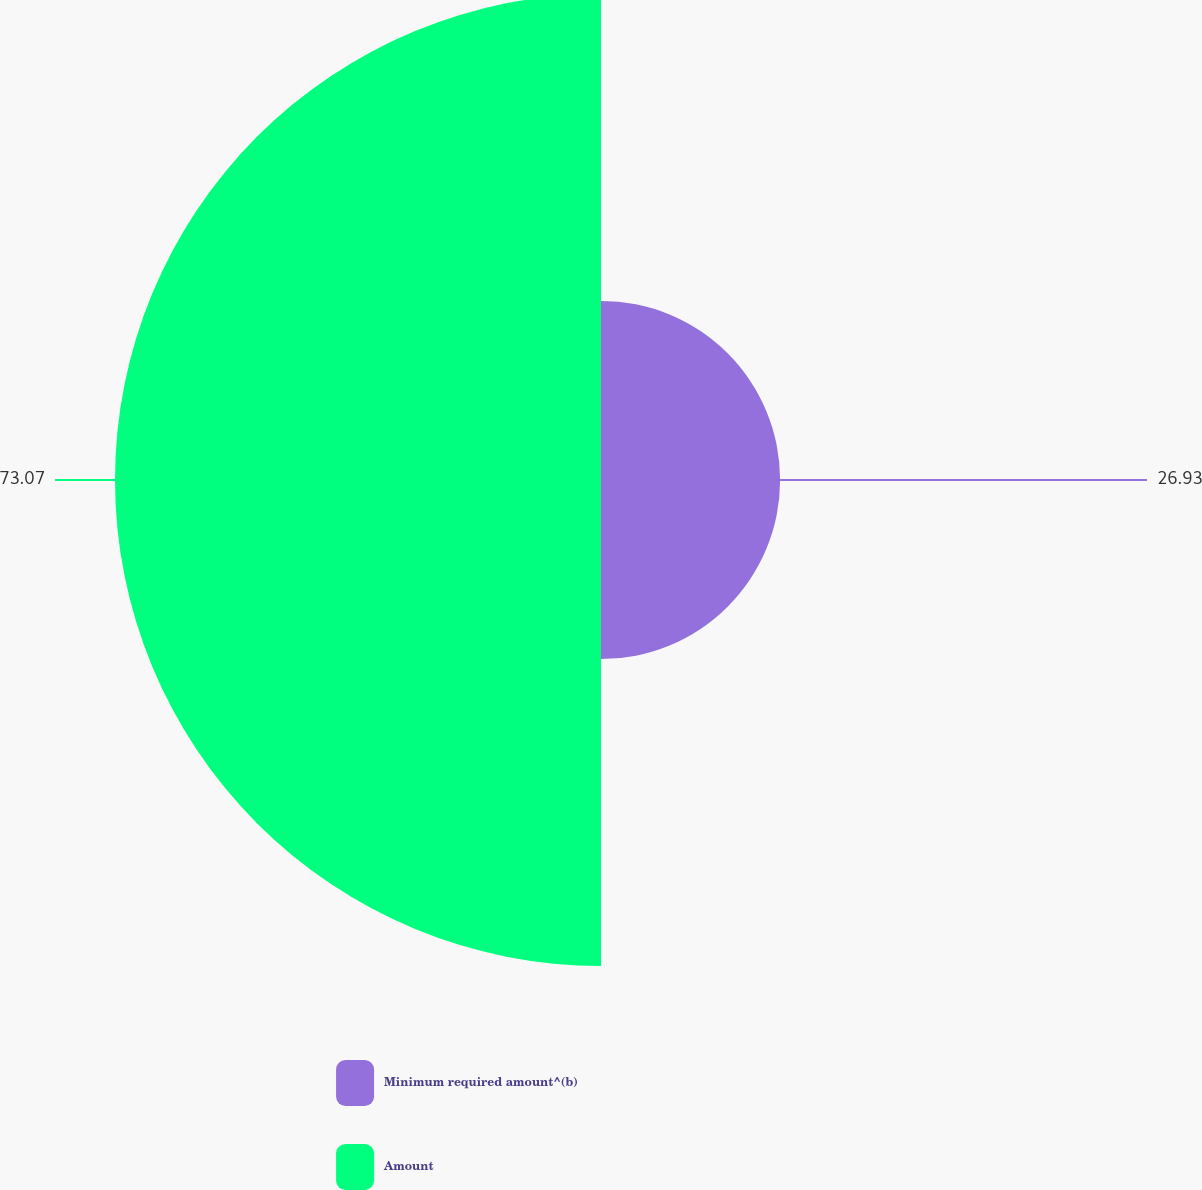Convert chart. <chart><loc_0><loc_0><loc_500><loc_500><pie_chart><fcel>Minimum required amount^(b)<fcel>Amount<nl><fcel>26.93%<fcel>73.07%<nl></chart> 